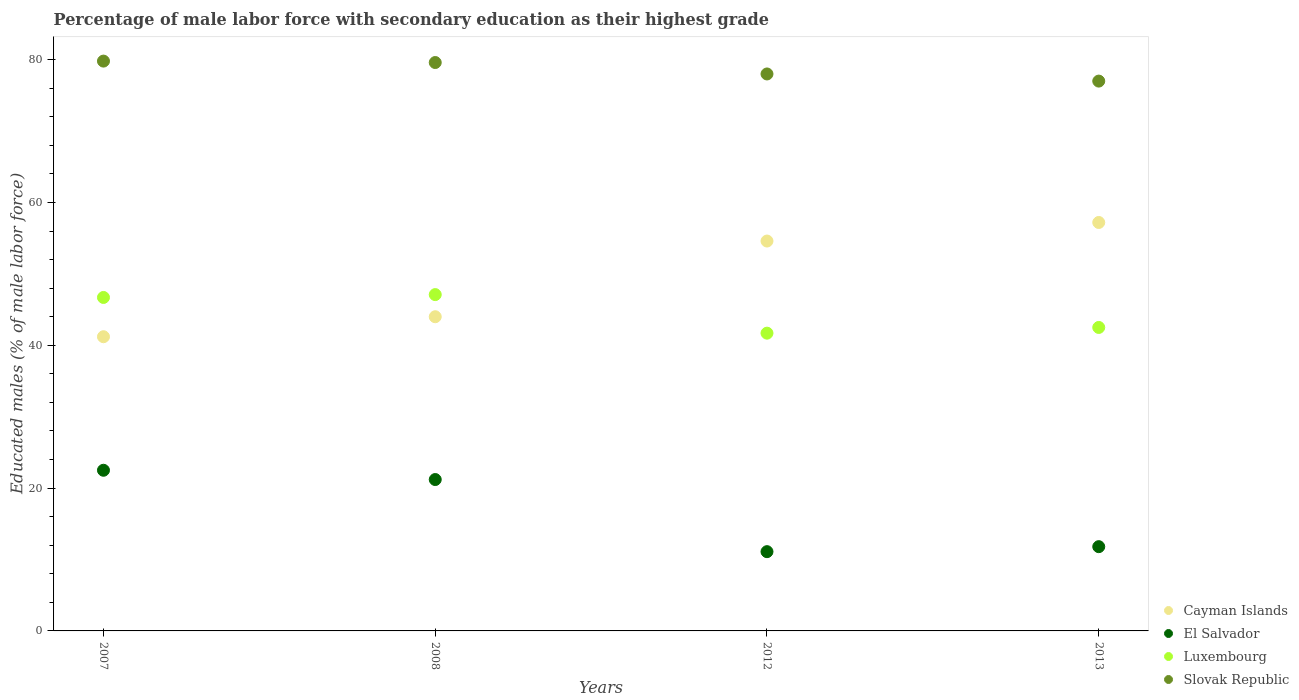Is the number of dotlines equal to the number of legend labels?
Your answer should be very brief. Yes. What is the percentage of male labor force with secondary education in Slovak Republic in 2008?
Your answer should be very brief. 79.6. Across all years, what is the maximum percentage of male labor force with secondary education in Cayman Islands?
Your answer should be compact. 57.2. Across all years, what is the minimum percentage of male labor force with secondary education in Luxembourg?
Provide a succinct answer. 41.7. In which year was the percentage of male labor force with secondary education in Luxembourg maximum?
Provide a short and direct response. 2008. In which year was the percentage of male labor force with secondary education in Cayman Islands minimum?
Your response must be concise. 2007. What is the total percentage of male labor force with secondary education in Cayman Islands in the graph?
Your answer should be compact. 197. What is the difference between the percentage of male labor force with secondary education in Luxembourg in 2007 and that in 2012?
Provide a short and direct response. 5. What is the difference between the percentage of male labor force with secondary education in El Salvador in 2007 and the percentage of male labor force with secondary education in Luxembourg in 2008?
Offer a terse response. -24.6. What is the average percentage of male labor force with secondary education in El Salvador per year?
Your answer should be compact. 16.65. In the year 2013, what is the difference between the percentage of male labor force with secondary education in Cayman Islands and percentage of male labor force with secondary education in Luxembourg?
Your answer should be compact. 14.7. In how many years, is the percentage of male labor force with secondary education in Slovak Republic greater than 20 %?
Make the answer very short. 4. What is the ratio of the percentage of male labor force with secondary education in Cayman Islands in 2012 to that in 2013?
Your answer should be compact. 0.95. Is the difference between the percentage of male labor force with secondary education in Cayman Islands in 2007 and 2013 greater than the difference between the percentage of male labor force with secondary education in Luxembourg in 2007 and 2013?
Provide a short and direct response. No. What is the difference between the highest and the second highest percentage of male labor force with secondary education in Cayman Islands?
Offer a very short reply. 2.6. What is the difference between the highest and the lowest percentage of male labor force with secondary education in Cayman Islands?
Your answer should be very brief. 16. Is the sum of the percentage of male labor force with secondary education in Cayman Islands in 2007 and 2013 greater than the maximum percentage of male labor force with secondary education in Slovak Republic across all years?
Your answer should be compact. Yes. Does the percentage of male labor force with secondary education in Cayman Islands monotonically increase over the years?
Your response must be concise. Yes. Is the percentage of male labor force with secondary education in El Salvador strictly greater than the percentage of male labor force with secondary education in Cayman Islands over the years?
Offer a terse response. No. Is the percentage of male labor force with secondary education in Cayman Islands strictly less than the percentage of male labor force with secondary education in Slovak Republic over the years?
Your answer should be very brief. Yes. How many years are there in the graph?
Ensure brevity in your answer.  4. What is the difference between two consecutive major ticks on the Y-axis?
Provide a short and direct response. 20. Are the values on the major ticks of Y-axis written in scientific E-notation?
Provide a short and direct response. No. How are the legend labels stacked?
Your response must be concise. Vertical. What is the title of the graph?
Give a very brief answer. Percentage of male labor force with secondary education as their highest grade. Does "Barbados" appear as one of the legend labels in the graph?
Offer a very short reply. No. What is the label or title of the Y-axis?
Your response must be concise. Educated males (% of male labor force). What is the Educated males (% of male labor force) of Cayman Islands in 2007?
Your answer should be compact. 41.2. What is the Educated males (% of male labor force) of El Salvador in 2007?
Ensure brevity in your answer.  22.5. What is the Educated males (% of male labor force) in Luxembourg in 2007?
Your answer should be very brief. 46.7. What is the Educated males (% of male labor force) in Slovak Republic in 2007?
Offer a terse response. 79.8. What is the Educated males (% of male labor force) of Cayman Islands in 2008?
Make the answer very short. 44. What is the Educated males (% of male labor force) in El Salvador in 2008?
Give a very brief answer. 21.2. What is the Educated males (% of male labor force) of Luxembourg in 2008?
Provide a succinct answer. 47.1. What is the Educated males (% of male labor force) in Slovak Republic in 2008?
Your response must be concise. 79.6. What is the Educated males (% of male labor force) of Cayman Islands in 2012?
Your answer should be compact. 54.6. What is the Educated males (% of male labor force) in El Salvador in 2012?
Your response must be concise. 11.1. What is the Educated males (% of male labor force) in Luxembourg in 2012?
Offer a very short reply. 41.7. What is the Educated males (% of male labor force) in Slovak Republic in 2012?
Ensure brevity in your answer.  78. What is the Educated males (% of male labor force) of Cayman Islands in 2013?
Provide a succinct answer. 57.2. What is the Educated males (% of male labor force) in El Salvador in 2013?
Your answer should be very brief. 11.8. What is the Educated males (% of male labor force) in Luxembourg in 2013?
Provide a short and direct response. 42.5. What is the Educated males (% of male labor force) of Slovak Republic in 2013?
Provide a succinct answer. 77. Across all years, what is the maximum Educated males (% of male labor force) in Cayman Islands?
Make the answer very short. 57.2. Across all years, what is the maximum Educated males (% of male labor force) in Luxembourg?
Offer a very short reply. 47.1. Across all years, what is the maximum Educated males (% of male labor force) in Slovak Republic?
Your response must be concise. 79.8. Across all years, what is the minimum Educated males (% of male labor force) in Cayman Islands?
Provide a succinct answer. 41.2. Across all years, what is the minimum Educated males (% of male labor force) of El Salvador?
Give a very brief answer. 11.1. Across all years, what is the minimum Educated males (% of male labor force) in Luxembourg?
Offer a very short reply. 41.7. Across all years, what is the minimum Educated males (% of male labor force) in Slovak Republic?
Your answer should be very brief. 77. What is the total Educated males (% of male labor force) in Cayman Islands in the graph?
Your answer should be very brief. 197. What is the total Educated males (% of male labor force) in El Salvador in the graph?
Offer a terse response. 66.6. What is the total Educated males (% of male labor force) of Luxembourg in the graph?
Provide a short and direct response. 178. What is the total Educated males (% of male labor force) of Slovak Republic in the graph?
Provide a short and direct response. 314.4. What is the difference between the Educated males (% of male labor force) of El Salvador in 2007 and that in 2008?
Provide a short and direct response. 1.3. What is the difference between the Educated males (% of male labor force) of Luxembourg in 2007 and that in 2008?
Make the answer very short. -0.4. What is the difference between the Educated males (% of male labor force) in Slovak Republic in 2007 and that in 2012?
Give a very brief answer. 1.8. What is the difference between the Educated males (% of male labor force) of Cayman Islands in 2007 and that in 2013?
Provide a succinct answer. -16. What is the difference between the Educated males (% of male labor force) in El Salvador in 2007 and that in 2013?
Provide a succinct answer. 10.7. What is the difference between the Educated males (% of male labor force) in El Salvador in 2008 and that in 2012?
Give a very brief answer. 10.1. What is the difference between the Educated males (% of male labor force) of Luxembourg in 2008 and that in 2013?
Offer a terse response. 4.6. What is the difference between the Educated males (% of male labor force) of Slovak Republic in 2008 and that in 2013?
Provide a short and direct response. 2.6. What is the difference between the Educated males (% of male labor force) in Cayman Islands in 2012 and that in 2013?
Provide a short and direct response. -2.6. What is the difference between the Educated males (% of male labor force) of Cayman Islands in 2007 and the Educated males (% of male labor force) of El Salvador in 2008?
Give a very brief answer. 20. What is the difference between the Educated males (% of male labor force) of Cayman Islands in 2007 and the Educated males (% of male labor force) of Slovak Republic in 2008?
Provide a succinct answer. -38.4. What is the difference between the Educated males (% of male labor force) of El Salvador in 2007 and the Educated males (% of male labor force) of Luxembourg in 2008?
Your answer should be compact. -24.6. What is the difference between the Educated males (% of male labor force) in El Salvador in 2007 and the Educated males (% of male labor force) in Slovak Republic in 2008?
Make the answer very short. -57.1. What is the difference between the Educated males (% of male labor force) of Luxembourg in 2007 and the Educated males (% of male labor force) of Slovak Republic in 2008?
Offer a terse response. -32.9. What is the difference between the Educated males (% of male labor force) in Cayman Islands in 2007 and the Educated males (% of male labor force) in El Salvador in 2012?
Ensure brevity in your answer.  30.1. What is the difference between the Educated males (% of male labor force) in Cayman Islands in 2007 and the Educated males (% of male labor force) in Slovak Republic in 2012?
Offer a very short reply. -36.8. What is the difference between the Educated males (% of male labor force) of El Salvador in 2007 and the Educated males (% of male labor force) of Luxembourg in 2012?
Your answer should be very brief. -19.2. What is the difference between the Educated males (% of male labor force) of El Salvador in 2007 and the Educated males (% of male labor force) of Slovak Republic in 2012?
Give a very brief answer. -55.5. What is the difference between the Educated males (% of male labor force) of Luxembourg in 2007 and the Educated males (% of male labor force) of Slovak Republic in 2012?
Keep it short and to the point. -31.3. What is the difference between the Educated males (% of male labor force) of Cayman Islands in 2007 and the Educated males (% of male labor force) of El Salvador in 2013?
Give a very brief answer. 29.4. What is the difference between the Educated males (% of male labor force) in Cayman Islands in 2007 and the Educated males (% of male labor force) in Slovak Republic in 2013?
Ensure brevity in your answer.  -35.8. What is the difference between the Educated males (% of male labor force) in El Salvador in 2007 and the Educated males (% of male labor force) in Slovak Republic in 2013?
Your response must be concise. -54.5. What is the difference between the Educated males (% of male labor force) of Luxembourg in 2007 and the Educated males (% of male labor force) of Slovak Republic in 2013?
Offer a very short reply. -30.3. What is the difference between the Educated males (% of male labor force) of Cayman Islands in 2008 and the Educated males (% of male labor force) of El Salvador in 2012?
Make the answer very short. 32.9. What is the difference between the Educated males (% of male labor force) in Cayman Islands in 2008 and the Educated males (% of male labor force) in Slovak Republic in 2012?
Offer a very short reply. -34. What is the difference between the Educated males (% of male labor force) of El Salvador in 2008 and the Educated males (% of male labor force) of Luxembourg in 2012?
Provide a succinct answer. -20.5. What is the difference between the Educated males (% of male labor force) of El Salvador in 2008 and the Educated males (% of male labor force) of Slovak Republic in 2012?
Your response must be concise. -56.8. What is the difference between the Educated males (% of male labor force) of Luxembourg in 2008 and the Educated males (% of male labor force) of Slovak Republic in 2012?
Your answer should be compact. -30.9. What is the difference between the Educated males (% of male labor force) of Cayman Islands in 2008 and the Educated males (% of male labor force) of El Salvador in 2013?
Make the answer very short. 32.2. What is the difference between the Educated males (% of male labor force) of Cayman Islands in 2008 and the Educated males (% of male labor force) of Slovak Republic in 2013?
Your answer should be very brief. -33. What is the difference between the Educated males (% of male labor force) in El Salvador in 2008 and the Educated males (% of male labor force) in Luxembourg in 2013?
Offer a terse response. -21.3. What is the difference between the Educated males (% of male labor force) of El Salvador in 2008 and the Educated males (% of male labor force) of Slovak Republic in 2013?
Your response must be concise. -55.8. What is the difference between the Educated males (% of male labor force) in Luxembourg in 2008 and the Educated males (% of male labor force) in Slovak Republic in 2013?
Offer a terse response. -29.9. What is the difference between the Educated males (% of male labor force) of Cayman Islands in 2012 and the Educated males (% of male labor force) of El Salvador in 2013?
Offer a very short reply. 42.8. What is the difference between the Educated males (% of male labor force) in Cayman Islands in 2012 and the Educated males (% of male labor force) in Slovak Republic in 2013?
Offer a terse response. -22.4. What is the difference between the Educated males (% of male labor force) in El Salvador in 2012 and the Educated males (% of male labor force) in Luxembourg in 2013?
Keep it short and to the point. -31.4. What is the difference between the Educated males (% of male labor force) of El Salvador in 2012 and the Educated males (% of male labor force) of Slovak Republic in 2013?
Provide a succinct answer. -65.9. What is the difference between the Educated males (% of male labor force) in Luxembourg in 2012 and the Educated males (% of male labor force) in Slovak Republic in 2013?
Give a very brief answer. -35.3. What is the average Educated males (% of male labor force) of Cayman Islands per year?
Offer a terse response. 49.25. What is the average Educated males (% of male labor force) in El Salvador per year?
Make the answer very short. 16.65. What is the average Educated males (% of male labor force) of Luxembourg per year?
Your answer should be compact. 44.5. What is the average Educated males (% of male labor force) of Slovak Republic per year?
Ensure brevity in your answer.  78.6. In the year 2007, what is the difference between the Educated males (% of male labor force) of Cayman Islands and Educated males (% of male labor force) of Slovak Republic?
Your response must be concise. -38.6. In the year 2007, what is the difference between the Educated males (% of male labor force) in El Salvador and Educated males (% of male labor force) in Luxembourg?
Provide a succinct answer. -24.2. In the year 2007, what is the difference between the Educated males (% of male labor force) of El Salvador and Educated males (% of male labor force) of Slovak Republic?
Ensure brevity in your answer.  -57.3. In the year 2007, what is the difference between the Educated males (% of male labor force) of Luxembourg and Educated males (% of male labor force) of Slovak Republic?
Your answer should be compact. -33.1. In the year 2008, what is the difference between the Educated males (% of male labor force) in Cayman Islands and Educated males (% of male labor force) in El Salvador?
Your answer should be compact. 22.8. In the year 2008, what is the difference between the Educated males (% of male labor force) in Cayman Islands and Educated males (% of male labor force) in Slovak Republic?
Offer a very short reply. -35.6. In the year 2008, what is the difference between the Educated males (% of male labor force) in El Salvador and Educated males (% of male labor force) in Luxembourg?
Your response must be concise. -25.9. In the year 2008, what is the difference between the Educated males (% of male labor force) of El Salvador and Educated males (% of male labor force) of Slovak Republic?
Your answer should be very brief. -58.4. In the year 2008, what is the difference between the Educated males (% of male labor force) in Luxembourg and Educated males (% of male labor force) in Slovak Republic?
Make the answer very short. -32.5. In the year 2012, what is the difference between the Educated males (% of male labor force) of Cayman Islands and Educated males (% of male labor force) of El Salvador?
Offer a very short reply. 43.5. In the year 2012, what is the difference between the Educated males (% of male labor force) of Cayman Islands and Educated males (% of male labor force) of Slovak Republic?
Ensure brevity in your answer.  -23.4. In the year 2012, what is the difference between the Educated males (% of male labor force) in El Salvador and Educated males (% of male labor force) in Luxembourg?
Your answer should be compact. -30.6. In the year 2012, what is the difference between the Educated males (% of male labor force) of El Salvador and Educated males (% of male labor force) of Slovak Republic?
Ensure brevity in your answer.  -66.9. In the year 2012, what is the difference between the Educated males (% of male labor force) in Luxembourg and Educated males (% of male labor force) in Slovak Republic?
Ensure brevity in your answer.  -36.3. In the year 2013, what is the difference between the Educated males (% of male labor force) of Cayman Islands and Educated males (% of male labor force) of El Salvador?
Give a very brief answer. 45.4. In the year 2013, what is the difference between the Educated males (% of male labor force) in Cayman Islands and Educated males (% of male labor force) in Slovak Republic?
Provide a short and direct response. -19.8. In the year 2013, what is the difference between the Educated males (% of male labor force) of El Salvador and Educated males (% of male labor force) of Luxembourg?
Your answer should be compact. -30.7. In the year 2013, what is the difference between the Educated males (% of male labor force) of El Salvador and Educated males (% of male labor force) of Slovak Republic?
Provide a short and direct response. -65.2. In the year 2013, what is the difference between the Educated males (% of male labor force) of Luxembourg and Educated males (% of male labor force) of Slovak Republic?
Provide a short and direct response. -34.5. What is the ratio of the Educated males (% of male labor force) of Cayman Islands in 2007 to that in 2008?
Offer a very short reply. 0.94. What is the ratio of the Educated males (% of male labor force) in El Salvador in 2007 to that in 2008?
Provide a short and direct response. 1.06. What is the ratio of the Educated males (% of male labor force) in Luxembourg in 2007 to that in 2008?
Your response must be concise. 0.99. What is the ratio of the Educated males (% of male labor force) in Cayman Islands in 2007 to that in 2012?
Ensure brevity in your answer.  0.75. What is the ratio of the Educated males (% of male labor force) of El Salvador in 2007 to that in 2012?
Provide a short and direct response. 2.03. What is the ratio of the Educated males (% of male labor force) in Luxembourg in 2007 to that in 2012?
Your answer should be very brief. 1.12. What is the ratio of the Educated males (% of male labor force) in Slovak Republic in 2007 to that in 2012?
Your answer should be very brief. 1.02. What is the ratio of the Educated males (% of male labor force) in Cayman Islands in 2007 to that in 2013?
Your answer should be very brief. 0.72. What is the ratio of the Educated males (% of male labor force) in El Salvador in 2007 to that in 2013?
Your response must be concise. 1.91. What is the ratio of the Educated males (% of male labor force) in Luxembourg in 2007 to that in 2013?
Your answer should be compact. 1.1. What is the ratio of the Educated males (% of male labor force) of Slovak Republic in 2007 to that in 2013?
Your answer should be compact. 1.04. What is the ratio of the Educated males (% of male labor force) in Cayman Islands in 2008 to that in 2012?
Your answer should be very brief. 0.81. What is the ratio of the Educated males (% of male labor force) of El Salvador in 2008 to that in 2012?
Your answer should be very brief. 1.91. What is the ratio of the Educated males (% of male labor force) of Luxembourg in 2008 to that in 2012?
Ensure brevity in your answer.  1.13. What is the ratio of the Educated males (% of male labor force) in Slovak Republic in 2008 to that in 2012?
Keep it short and to the point. 1.02. What is the ratio of the Educated males (% of male labor force) in Cayman Islands in 2008 to that in 2013?
Offer a terse response. 0.77. What is the ratio of the Educated males (% of male labor force) of El Salvador in 2008 to that in 2013?
Offer a very short reply. 1.8. What is the ratio of the Educated males (% of male labor force) of Luxembourg in 2008 to that in 2013?
Your answer should be very brief. 1.11. What is the ratio of the Educated males (% of male labor force) in Slovak Republic in 2008 to that in 2013?
Offer a very short reply. 1.03. What is the ratio of the Educated males (% of male labor force) of Cayman Islands in 2012 to that in 2013?
Offer a very short reply. 0.95. What is the ratio of the Educated males (% of male labor force) in El Salvador in 2012 to that in 2013?
Give a very brief answer. 0.94. What is the ratio of the Educated males (% of male labor force) in Luxembourg in 2012 to that in 2013?
Offer a terse response. 0.98. What is the ratio of the Educated males (% of male labor force) in Slovak Republic in 2012 to that in 2013?
Your answer should be compact. 1.01. What is the difference between the highest and the second highest Educated males (% of male labor force) of El Salvador?
Provide a succinct answer. 1.3. What is the difference between the highest and the second highest Educated males (% of male labor force) in Luxembourg?
Your answer should be very brief. 0.4. What is the difference between the highest and the second highest Educated males (% of male labor force) of Slovak Republic?
Offer a terse response. 0.2. What is the difference between the highest and the lowest Educated males (% of male labor force) of Luxembourg?
Keep it short and to the point. 5.4. 